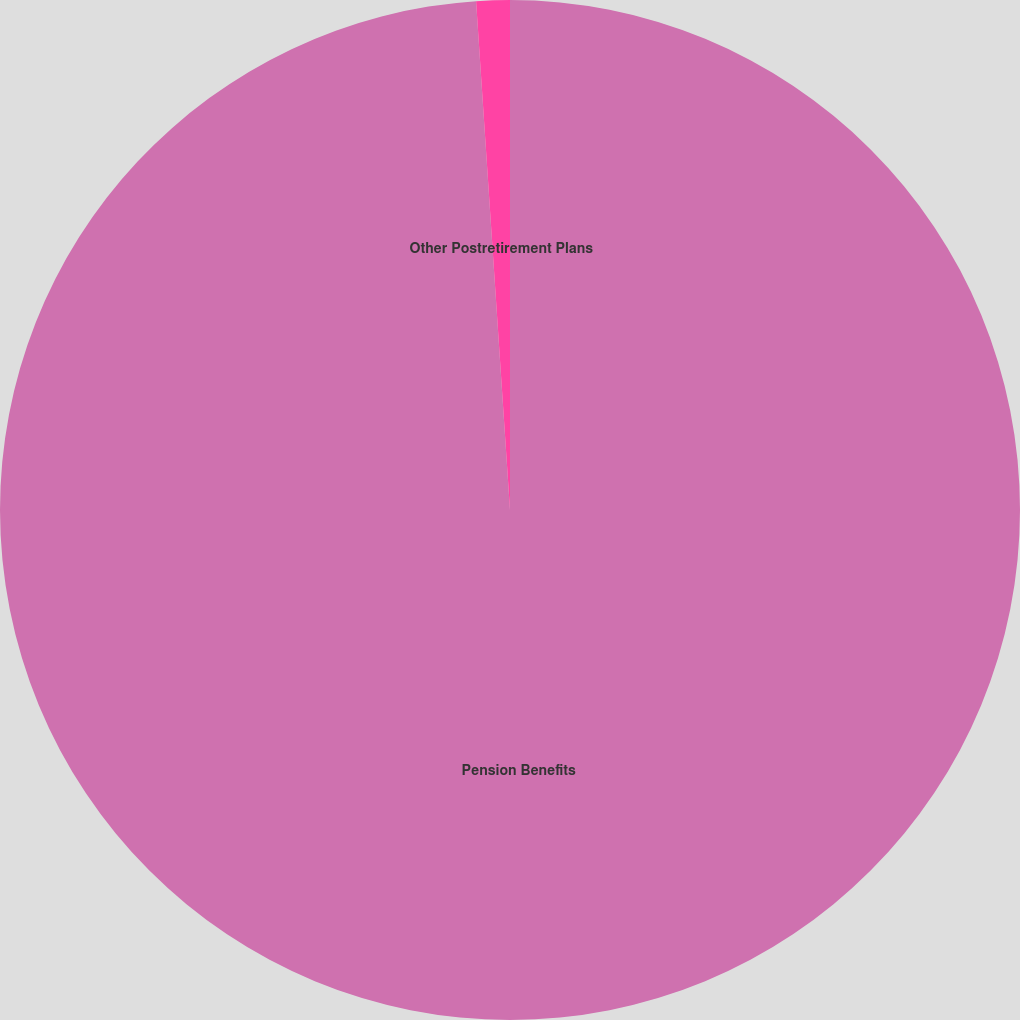<chart> <loc_0><loc_0><loc_500><loc_500><pie_chart><fcel>Pension Benefits<fcel>Other Postretirement Plans<nl><fcel>98.94%<fcel>1.06%<nl></chart> 